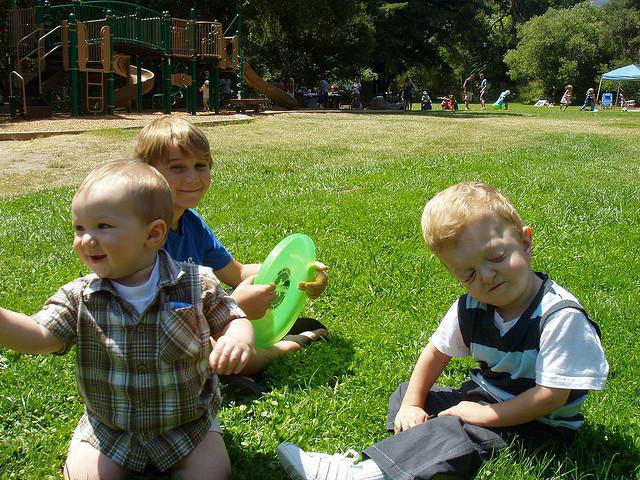Is it sunny in the picture?
Keep it brief. Yes. How many children are in this picture?
Concise answer only. 3. What color is the frisbee?
Write a very short answer. Green. 